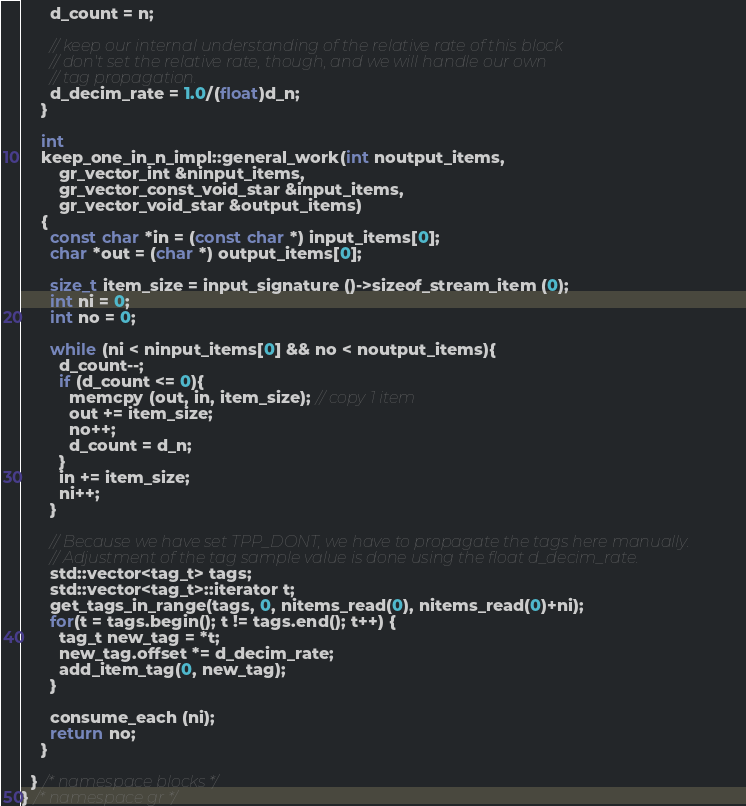<code> <loc_0><loc_0><loc_500><loc_500><_C++_>      d_count = n;

      // keep our internal understanding of the relative rate of this block
      // don't set the relative rate, though, and we will handle our own
      // tag propagation.
      d_decim_rate = 1.0/(float)d_n;
    }

    int
    keep_one_in_n_impl::general_work(int noutput_items,
        gr_vector_int &ninput_items,
        gr_vector_const_void_star &input_items,
        gr_vector_void_star &output_items)
    {
      const char *in = (const char *) input_items[0];
      char *out = (char *) output_items[0];

      size_t item_size = input_signature ()->sizeof_stream_item (0);
      int ni = 0;
      int no = 0;

      while (ni < ninput_items[0] && no < noutput_items){
        d_count--;
        if (d_count <= 0){
          memcpy (out, in, item_size); // copy 1 item
          out += item_size;
          no++;
          d_count = d_n;
        }
        in += item_size;
        ni++;
      }

      // Because we have set TPP_DONT, we have to propagate the tags here manually.
      // Adjustment of the tag sample value is done using the float d_decim_rate.
      std::vector<tag_t> tags;
      std::vector<tag_t>::iterator t;
      get_tags_in_range(tags, 0, nitems_read(0), nitems_read(0)+ni);
      for(t = tags.begin(); t != tags.end(); t++) {
        tag_t new_tag = *t;
        new_tag.offset *= d_decim_rate;
        add_item_tag(0, new_tag);
      }

      consume_each (ni);
      return no;
    }

  } /* namespace blocks */
} /* namespace gr */
</code> 